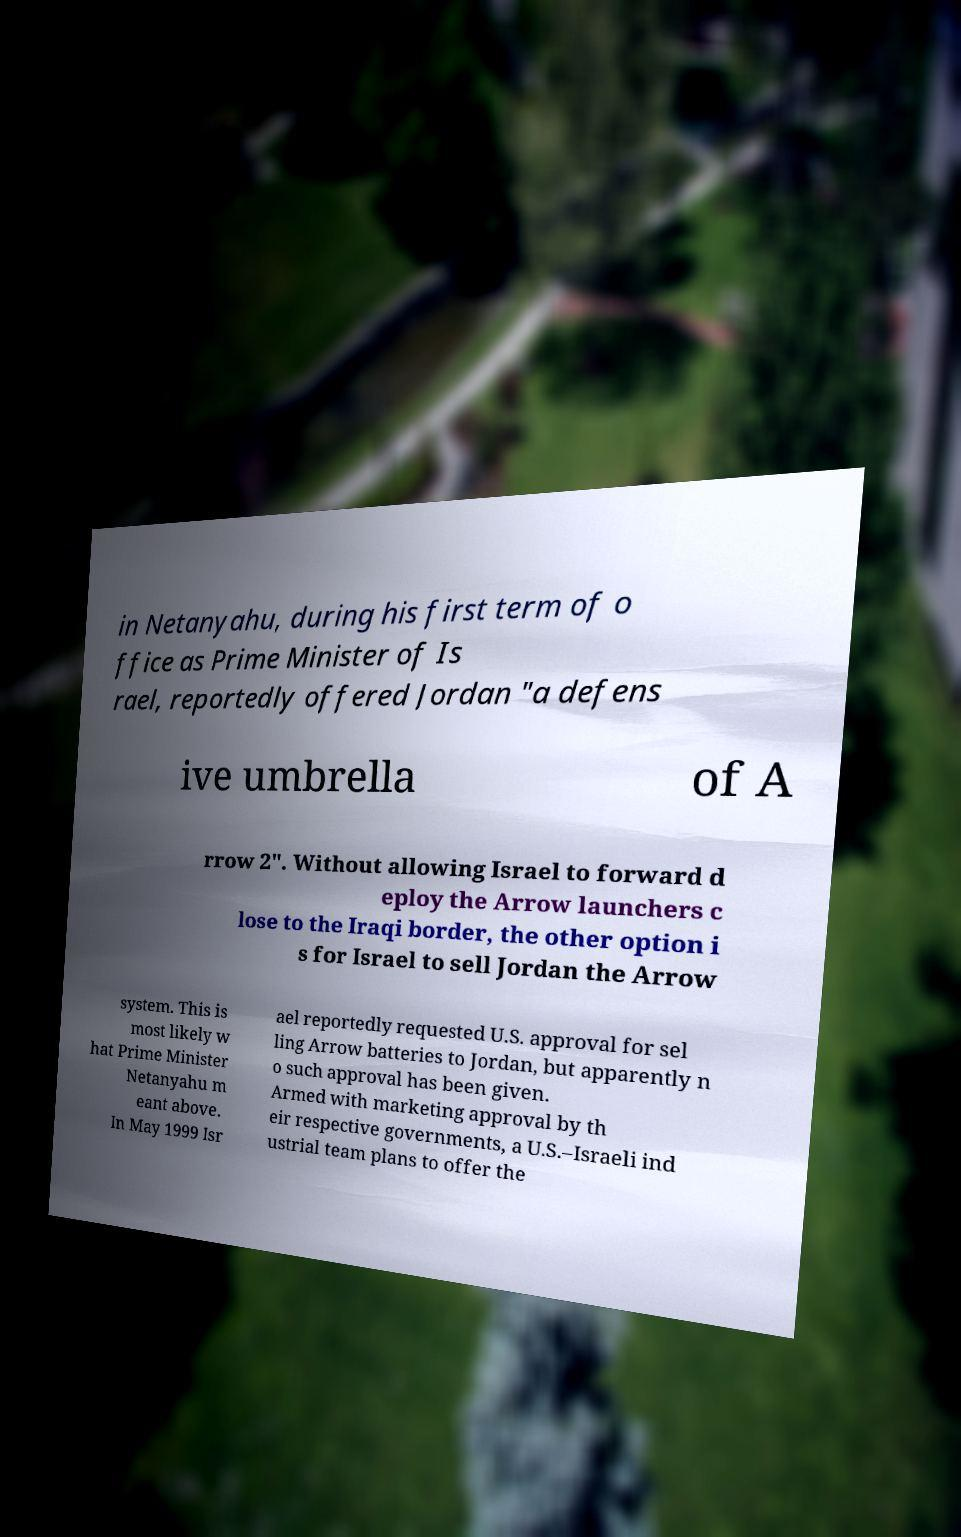I need the written content from this picture converted into text. Can you do that? in Netanyahu, during his first term of o ffice as Prime Minister of Is rael, reportedly offered Jordan "a defens ive umbrella of A rrow 2". Without allowing Israel to forward d eploy the Arrow launchers c lose to the Iraqi border, the other option i s for Israel to sell Jordan the Arrow system. This is most likely w hat Prime Minister Netanyahu m eant above. In May 1999 Isr ael reportedly requested U.S. approval for sel ling Arrow batteries to Jordan, but apparently n o such approval has been given. Armed with marketing approval by th eir respective governments, a U.S.–Israeli ind ustrial team plans to offer the 